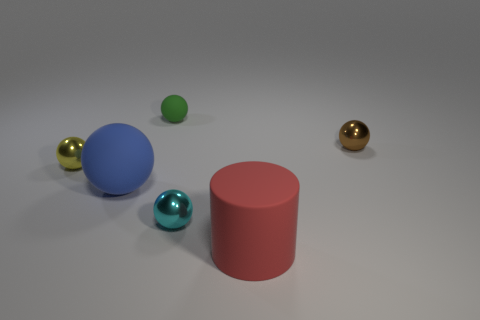Are there any large red rubber cylinders in front of the rubber thing that is in front of the metal thing that is in front of the small yellow thing?
Give a very brief answer. No. What number of small objects are blue metal balls or metal spheres?
Your answer should be compact. 3. Is there anything else that is the same color as the big matte sphere?
Offer a very short reply. No. Do the rubber ball behind the brown thing and the big blue matte thing have the same size?
Your answer should be very brief. No. What is the color of the large rubber thing that is left of the rubber object behind the large thing that is behind the red rubber thing?
Your response must be concise. Blue. What color is the big matte cylinder?
Your response must be concise. Red. Does the big matte cylinder have the same color as the tiny matte sphere?
Offer a terse response. No. Do the big object that is in front of the tiny cyan thing and the small ball in front of the yellow thing have the same material?
Provide a succinct answer. No. There is a green object that is the same shape as the large blue thing; what is its material?
Ensure brevity in your answer.  Rubber. Are the tiny green ball and the red thing made of the same material?
Offer a terse response. Yes. 